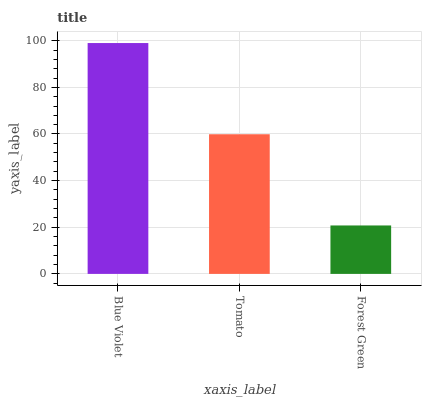Is Forest Green the minimum?
Answer yes or no. Yes. Is Blue Violet the maximum?
Answer yes or no. Yes. Is Tomato the minimum?
Answer yes or no. No. Is Tomato the maximum?
Answer yes or no. No. Is Blue Violet greater than Tomato?
Answer yes or no. Yes. Is Tomato less than Blue Violet?
Answer yes or no. Yes. Is Tomato greater than Blue Violet?
Answer yes or no. No. Is Blue Violet less than Tomato?
Answer yes or no. No. Is Tomato the high median?
Answer yes or no. Yes. Is Tomato the low median?
Answer yes or no. Yes. Is Blue Violet the high median?
Answer yes or no. No. Is Forest Green the low median?
Answer yes or no. No. 